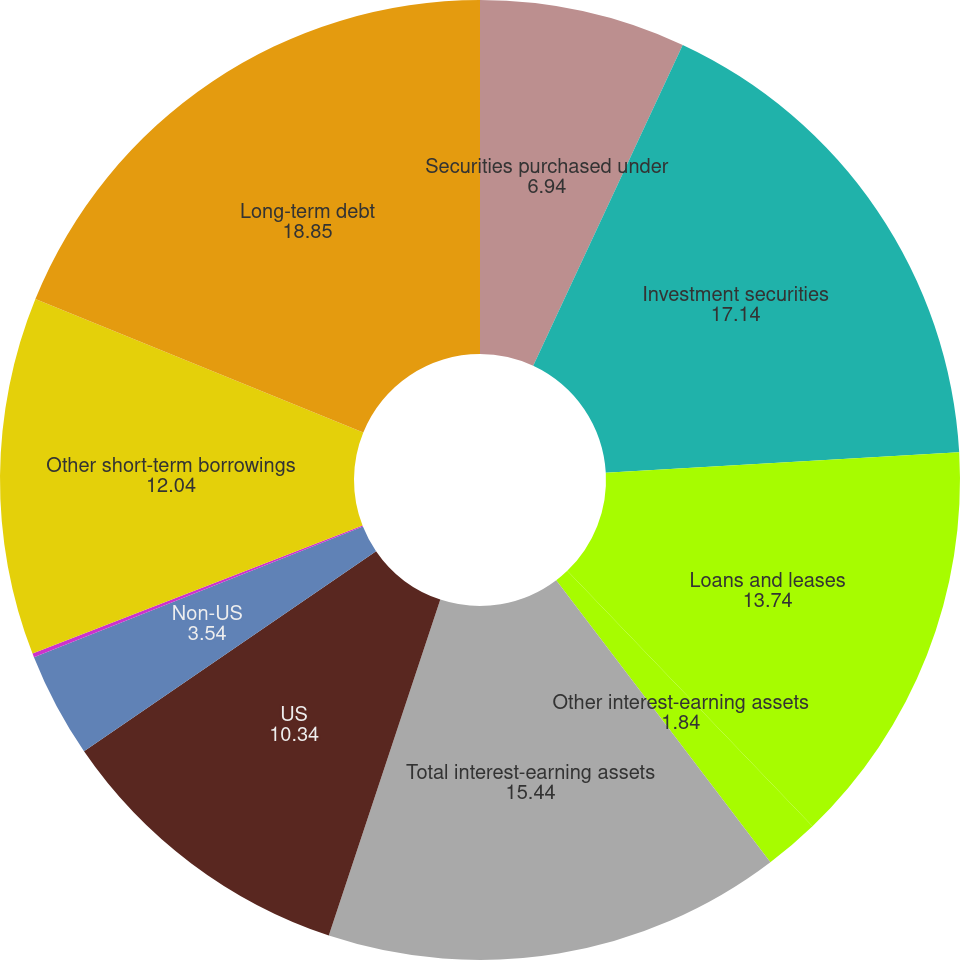Convert chart to OTSL. <chart><loc_0><loc_0><loc_500><loc_500><pie_chart><fcel>Securities purchased under<fcel>Investment securities<fcel>Loans and leases<fcel>Other interest-earning assets<fcel>Total interest-earning assets<fcel>US<fcel>Non-US<fcel>Securities sold under<fcel>Other short-term borrowings<fcel>Long-term debt<nl><fcel>6.94%<fcel>17.14%<fcel>13.74%<fcel>1.84%<fcel>15.44%<fcel>10.34%<fcel>3.54%<fcel>0.13%<fcel>12.04%<fcel>18.85%<nl></chart> 